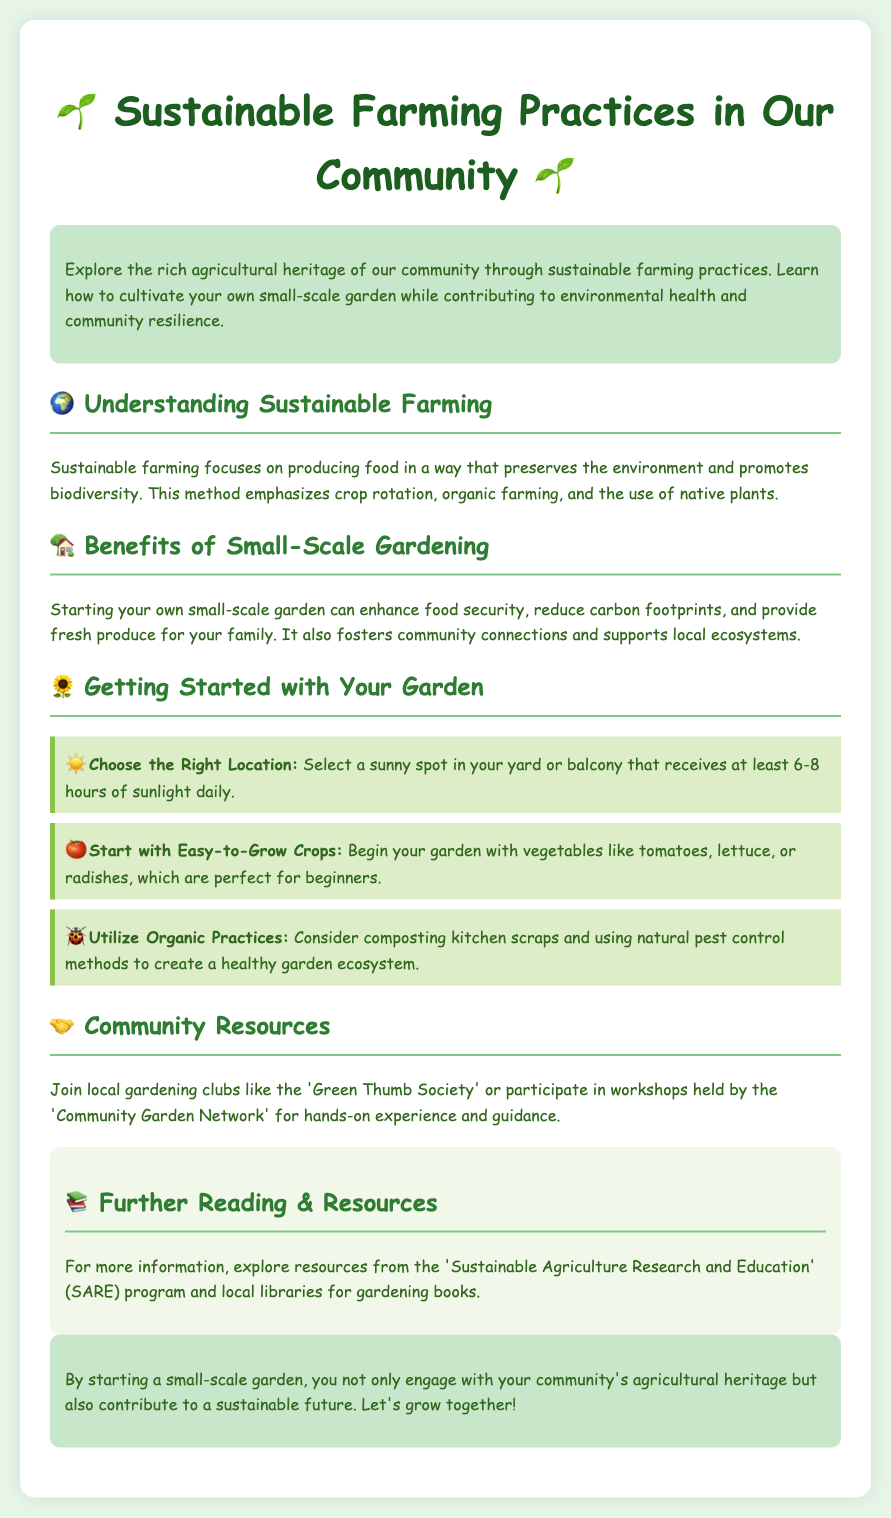what is the title of the document? The title of the document is highlighted at the top of the content, indicating its focus on sustainable farming.
Answer: Sustainable Farming Practices in Our Community what emoji is used in the title? The emoji in the title represents the theme of gardening and sustainability.
Answer: 🌱 how many hours of sunlight should a garden receive? The document specifies the ideal sunlight duration for a garden location.
Answer: 6-8 hours which society can community members join for gardening? The 'Green Thumb Society' is mentioned as a local gardening club for community involvement.
Answer: Green Thumb Society name one easy-to-grow crop suggested for beginners. The document provides examples of vegetables suitable for novice gardeners.
Answer: tomatoes what is one benefit of small-scale gardening? A benefit is highlighted that relates to food availability and community engagement.
Answer: food security what type of practices should be utilized in gardening according to the brochure? The document suggests specific types of farming approaches that are environmentally friendly.
Answer: Organic practices what organization offers resources for further reading? The document includes a program that provides additional materials on sustainable agriculture.
Answer: Sustainable Agriculture Research and Education what is the main goal of sustainable farming? The main aim of sustainable farming is described in the document, focusing on environmental aspects.
Answer: Preserve the environment 